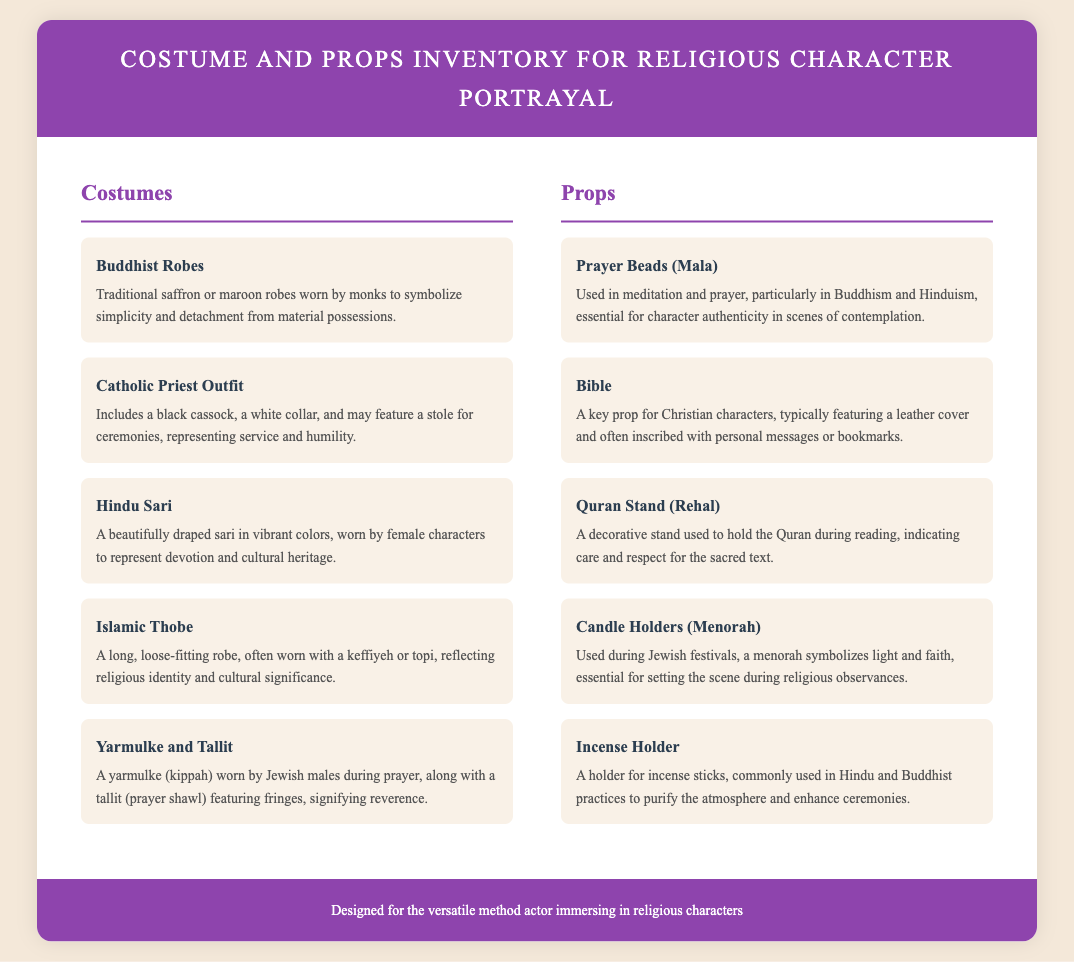What are the costumes listed? The document contains a section for costumes, specifying different types like Buddhist Robes, Catholic Priest Outfit, etc.
Answer: Buddhist Robes, Catholic Priest Outfit, Hindu Sari, Islamic Thobe, Yarmulke and Tallit What is the description of the Islamic Thobe? The description provides specific details about the outfit, its cultural significance, and common accompaniments.
Answer: A long, loose-fitting robe, often worn with a keffiyeh or topi, reflecting religious identity and cultural significance How many props are listed in the document? By counting the items under the props category, one can determine the total.
Answer: Five What is the significance of the Yarmulke and Tallit? This question requires understanding the meaning associated with Jewish prayer attire presented in the document.
Answer: Signifying reverence What type of prayer beads are mentioned? The document specifies a particular type of prayer beads used in certain religions.
Answer: Mala What color are the Buddhist Robes? The description in the document mentions specific colors associated with Buddhist attire.
Answer: Saffron or maroon What does the Quran Stand indicate? The explanation of the Quran Stand in the document delves into its symbolic meaning during reading.
Answer: Care and respect for the sacred text How does the Candle Holders (Menorah) function in religious practice? This question seeks to connect a prop to its religious context or usage as defined in the document.
Answer: Used during Jewish festivals What is the document designed for? The footer provides a succinct summary of the purpose of the document.
Answer: The versatile method actor immersing in religious characters 